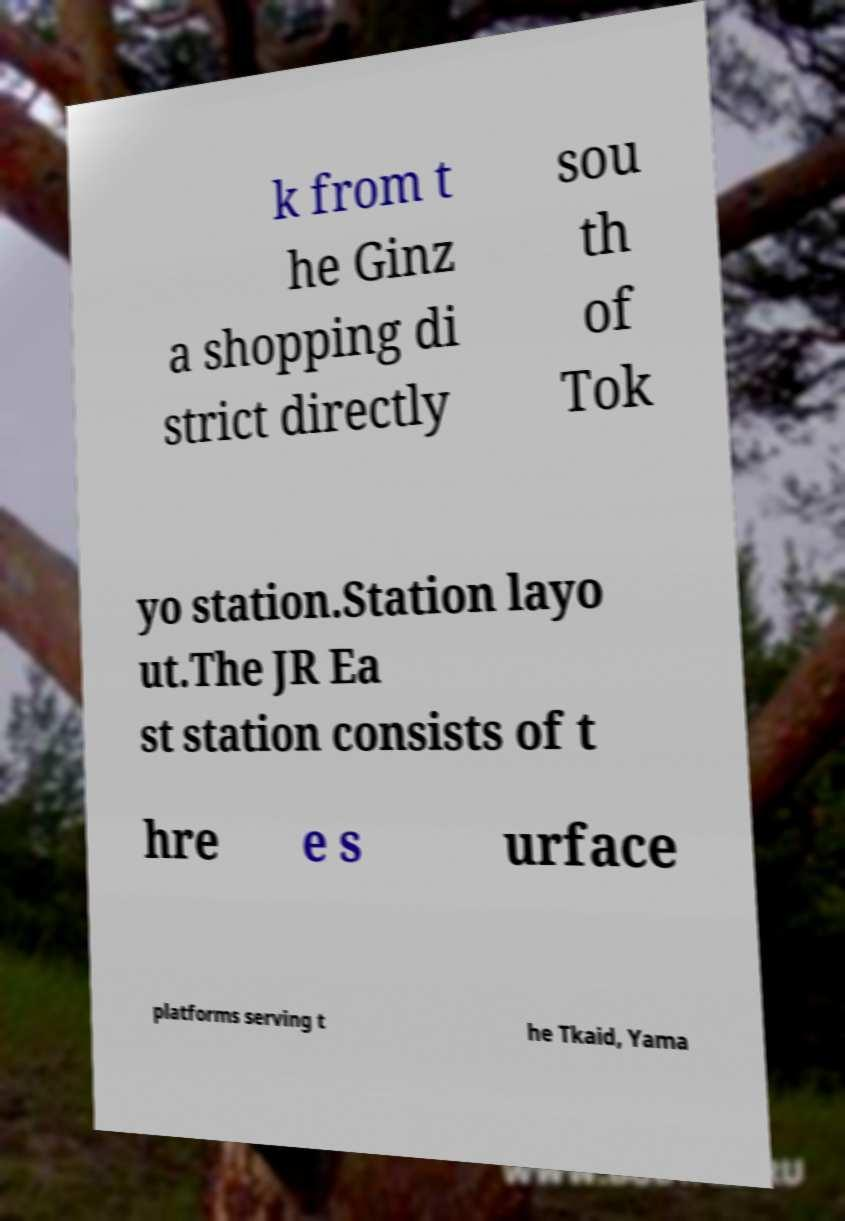Can you read and provide the text displayed in the image?This photo seems to have some interesting text. Can you extract and type it out for me? k from t he Ginz a shopping di strict directly sou th of Tok yo station.Station layo ut.The JR Ea st station consists of t hre e s urface platforms serving t he Tkaid, Yama 